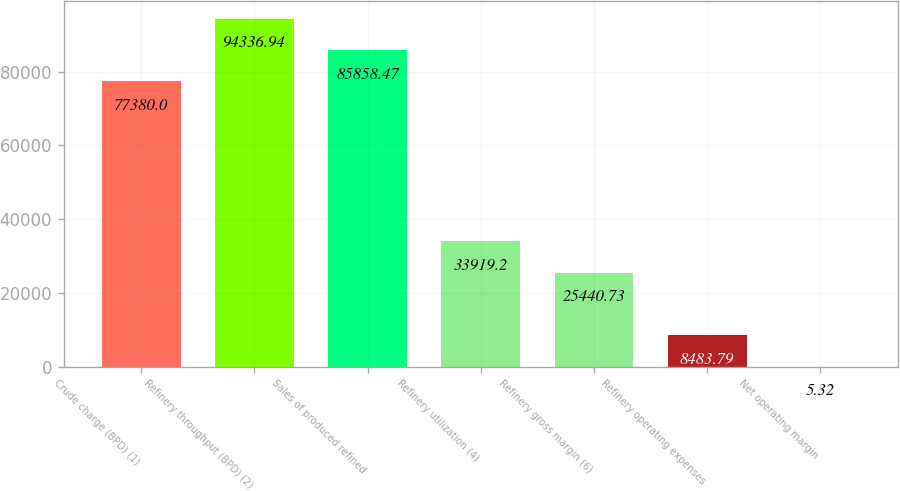<chart> <loc_0><loc_0><loc_500><loc_500><bar_chart><fcel>Crude charge (BPD) (1)<fcel>Refinery throughput (BPD) (2)<fcel>Sales of produced refined<fcel>Refinery utilization (4)<fcel>Refinery gross margin (6)<fcel>Refinery operating expenses<fcel>Net operating margin<nl><fcel>77380<fcel>94336.9<fcel>85858.5<fcel>33919.2<fcel>25440.7<fcel>8483.79<fcel>5.32<nl></chart> 